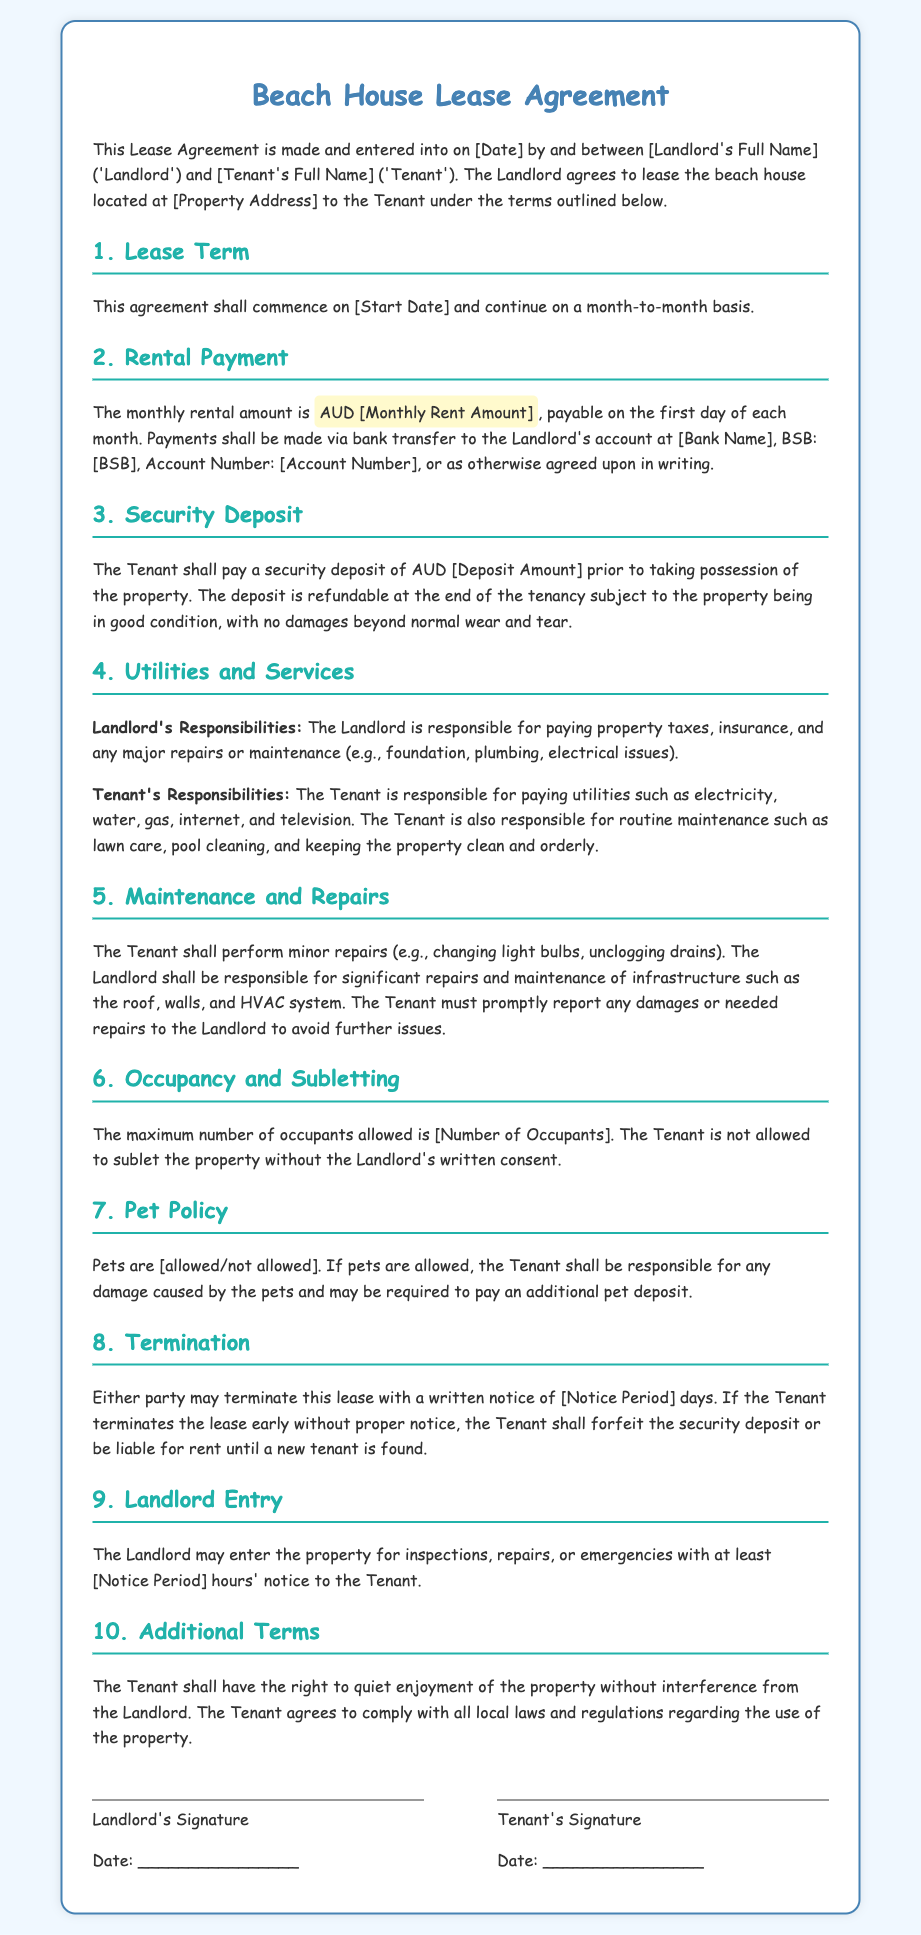What is the monthly rent amount? The monthly rent amount is specified as AUD [Monthly Rent Amount] in the document.
Answer: AUD [Monthly Rent Amount] Who is the landlord? The document outlines the landlord's name as [Landlord's Full Name].
Answer: [Landlord's Full Name] What is the security deposit amount? The security deposit is mentioned as AUD [Deposit Amount].
Answer: AUD [Deposit Amount] What is the notice period for termination? The notice period for termination is stated as [Notice Period] days in the document.
Answer: [Notice Period] Are pets allowed? The document explicitly states whether pets are allowed or not; the answer is [allowed/not allowed].
Answer: [allowed/not allowed] What is the duration of the lease? The lease agreement specifies that it continues on a month-to-month basis.
Answer: month-to-month What is the tenant responsible for regarding utilities? The tenant is responsible for paying utilities such as electricity, water, gas, internet, and television.
Answer: utilities What must the tenant do for minor repairs? The tenant must perform minor repairs like changing light bulbs and unclogging drains.
Answer: minor repairs How many occupants are allowed? The maximum number of occupants allowed is indicated as [Number of Occupants].
Answer: [Number of Occupants] What must be reported to the landlord? The tenant must promptly report any damages or needed repairs to the landlord.
Answer: damages or needed repairs 